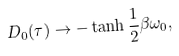<formula> <loc_0><loc_0><loc_500><loc_500>D _ { 0 } ( \tau ) \rightarrow - \tanh \frac { 1 } { 2 } \beta \omega _ { 0 } ,</formula> 